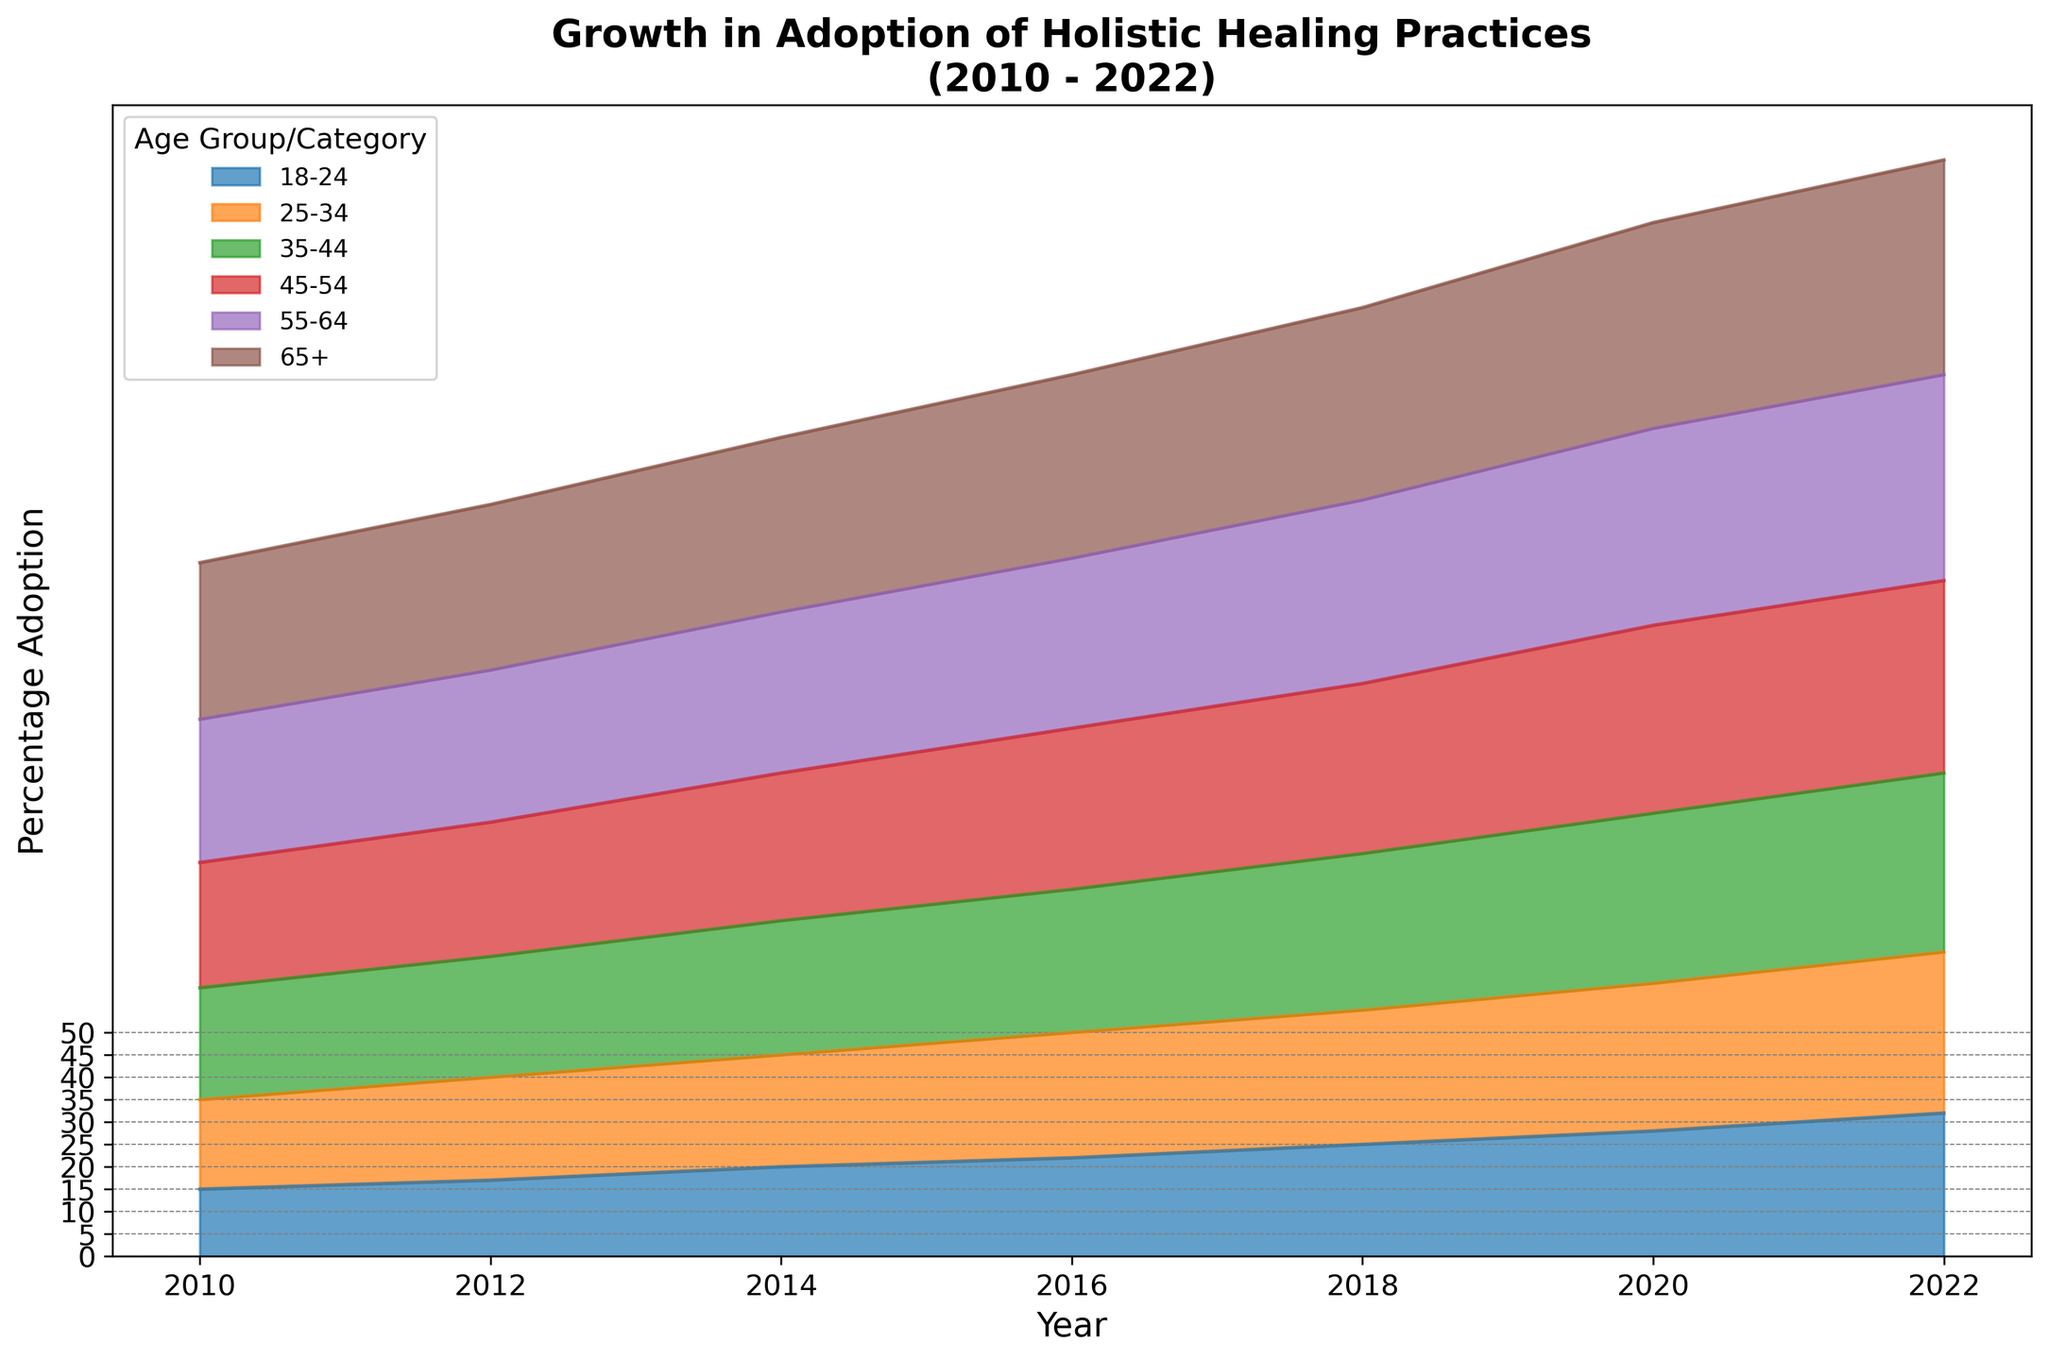What overall trend do you observe in the adoption of holistic healing practices from 2010 to 2022? By examining the area chart, we see that adoption rates for all age groups increased over the years. The chart shows a consistent upward trend, indicating a growing adoption of holistic healing practices across all age groups.
Answer: Increasing trend Which age group showed the highest adoption rate in 2022? In 2022, the section of the chart with the highest vertical extent (topmost part) is the 65+ age group.
Answer: 65+ How much did the adoption rate change for the 35-44 age group from 2010 to 2022? In 2010, the adoption rate for the 35-44 age group was 25% and increased to 40% in 2022. The change in the adoption rate is 40% - 25% = 15%.
Answer: 15% In what year did the 18-24 age group see its adoption rate reach 25%? The chart shows that the area corresponding to the 18-24 age group reaches the 25% mark in the year 2018.
Answer: 2018 Which age group had the smallest increase in the adoption rate between 2010 and 2012? By comparing the vertical distance between the 2010 and 2012 sections for each age group, the 45-54 age group showed an increase from 28% to 30%, which is 2%. This is the smallest increase among all age groups.
Answer: 45-54 What is the difference in the adoption rate of holistic healing practices between the 25-34 and 55-64 age groups in 2016? In 2016, the 25-34 age group had an adoption rate of 28%, and the 55-64 age group had an adoption rate of 38%. The difference is 38% - 28% = 10%.
Answer: 10% In which year did the 45-54 age group surpass the 35-44 age group in adoption rate? The chart illustrates that in 2016, the adoption rate of the 45-54 age group (36%) was greater than that of the 35-44 age group (32%). This is the first year the 45-54 group surpassed the 35-44 group.
Answer: 2016 Which age group experienced the highest percentage increase in adoption rate from 2010 to 2022? First, calculate the percentage increase for each age group from 2010 to 2022. For the 65+ age group, the increase is from 35% to 48%: (48 - 35) / 35 * 100 ≈ 37.14%. After calculating for all age groups, the 18-24 age group shows an increase from 15% to 32%, which is the highest percentage increase of (32 - 15) / 15 * 100 ≈ 113.33%.
Answer: 18-24 